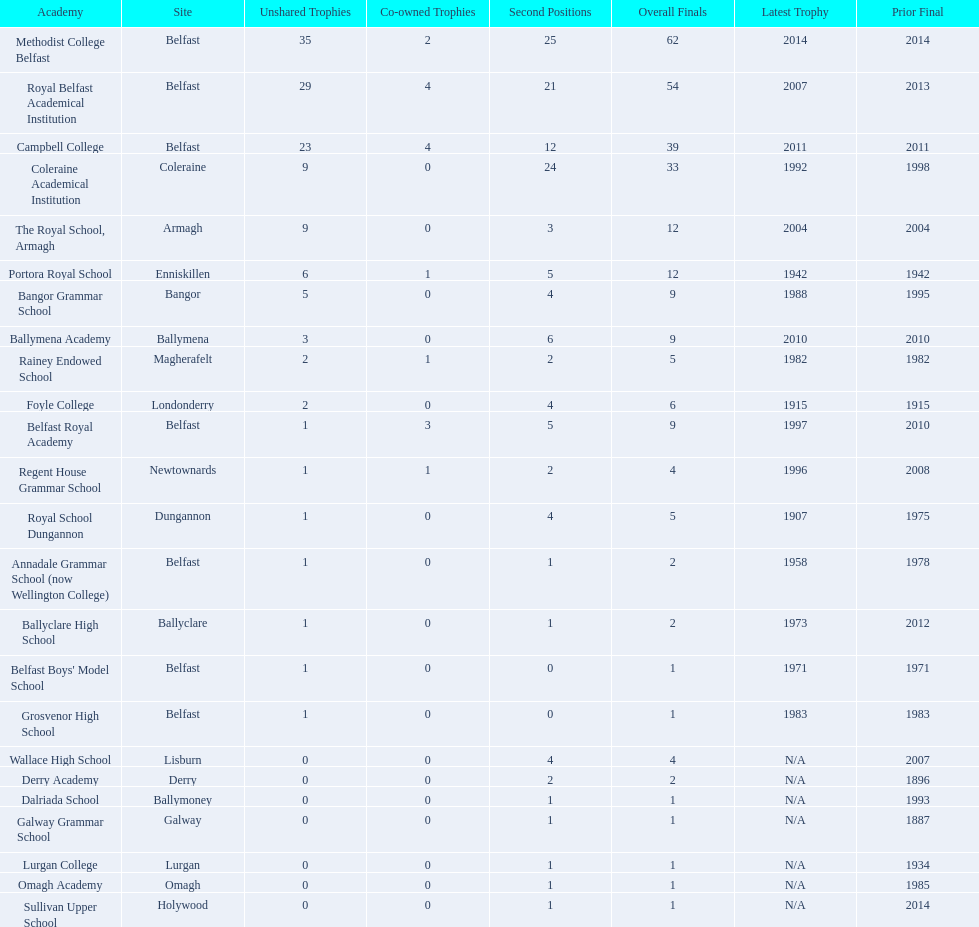What is the most recent win of campbell college? 2011. What is the most recent win of regent house grammar school? 1996. Which date is more recent? 2011. What is the name of the school with this date? Campbell College. Would you mind parsing the complete table? {'header': ['Academy', 'Site', 'Unshared Trophies', 'Co-owned Trophies', 'Second Positions', 'Overall Finals', 'Latest Trophy', 'Prior Final'], 'rows': [['Methodist College Belfast', 'Belfast', '35', '2', '25', '62', '2014', '2014'], ['Royal Belfast Academical Institution', 'Belfast', '29', '4', '21', '54', '2007', '2013'], ['Campbell College', 'Belfast', '23', '4', '12', '39', '2011', '2011'], ['Coleraine Academical Institution', 'Coleraine', '9', '0', '24', '33', '1992', '1998'], ['The Royal School, Armagh', 'Armagh', '9', '0', '3', '12', '2004', '2004'], ['Portora Royal School', 'Enniskillen', '6', '1', '5', '12', '1942', '1942'], ['Bangor Grammar School', 'Bangor', '5', '0', '4', '9', '1988', '1995'], ['Ballymena Academy', 'Ballymena', '3', '0', '6', '9', '2010', '2010'], ['Rainey Endowed School', 'Magherafelt', '2', '1', '2', '5', '1982', '1982'], ['Foyle College', 'Londonderry', '2', '0', '4', '6', '1915', '1915'], ['Belfast Royal Academy', 'Belfast', '1', '3', '5', '9', '1997', '2010'], ['Regent House Grammar School', 'Newtownards', '1', '1', '2', '4', '1996', '2008'], ['Royal School Dungannon', 'Dungannon', '1', '0', '4', '5', '1907', '1975'], ['Annadale Grammar School (now Wellington College)', 'Belfast', '1', '0', '1', '2', '1958', '1978'], ['Ballyclare High School', 'Ballyclare', '1', '0', '1', '2', '1973', '2012'], ["Belfast Boys' Model School", 'Belfast', '1', '0', '0', '1', '1971', '1971'], ['Grosvenor High School', 'Belfast', '1', '0', '0', '1', '1983', '1983'], ['Wallace High School', 'Lisburn', '0', '0', '4', '4', 'N/A', '2007'], ['Derry Academy', 'Derry', '0', '0', '2', '2', 'N/A', '1896'], ['Dalriada School', 'Ballymoney', '0', '0', '1', '1', 'N/A', '1993'], ['Galway Grammar School', 'Galway', '0', '0', '1', '1', 'N/A', '1887'], ['Lurgan College', 'Lurgan', '0', '0', '1', '1', 'N/A', '1934'], ['Omagh Academy', 'Omagh', '0', '0', '1', '1', 'N/A', '1985'], ['Sullivan Upper School', 'Holywood', '0', '0', '1', '1', 'N/A', '2014']]} 